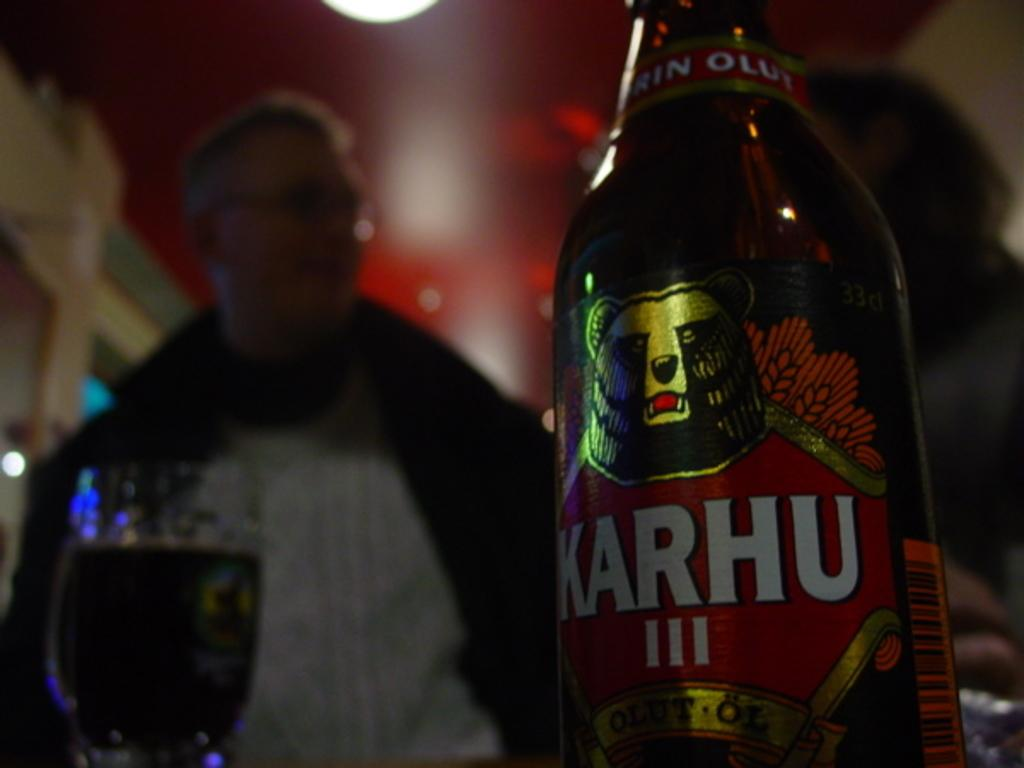<image>
Present a compact description of the photo's key features. A BOTTLE OF BEER WITH A LABEL THAT READS KARHU III 